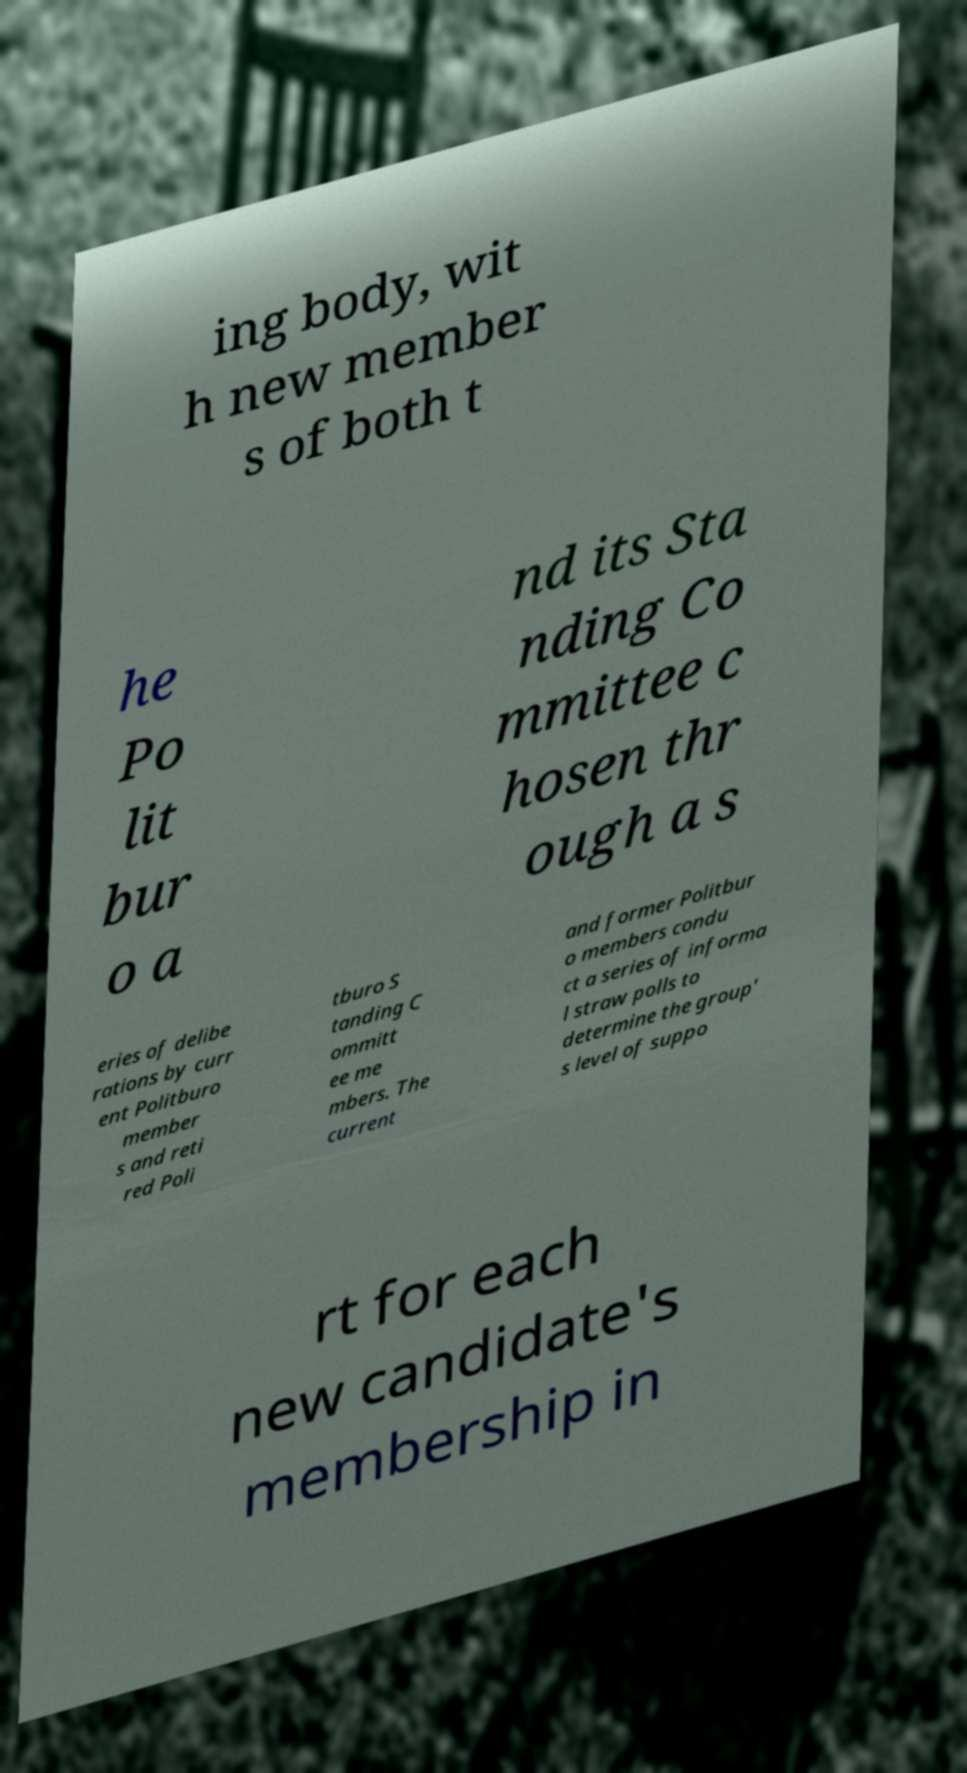Could you extract and type out the text from this image? ing body, wit h new member s of both t he Po lit bur o a nd its Sta nding Co mmittee c hosen thr ough a s eries of delibe rations by curr ent Politburo member s and reti red Poli tburo S tanding C ommitt ee me mbers. The current and former Politbur o members condu ct a series of informa l straw polls to determine the group' s level of suppo rt for each new candidate's membership in 